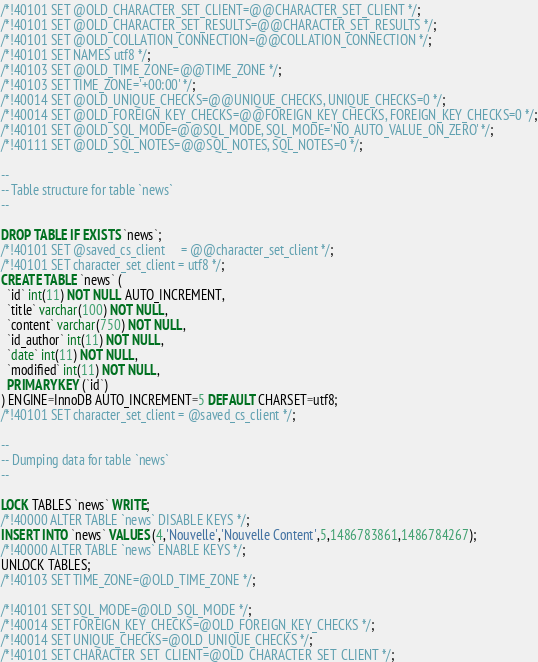<code> <loc_0><loc_0><loc_500><loc_500><_SQL_>/*!40101 SET @OLD_CHARACTER_SET_CLIENT=@@CHARACTER_SET_CLIENT */;
/*!40101 SET @OLD_CHARACTER_SET_RESULTS=@@CHARACTER_SET_RESULTS */;
/*!40101 SET @OLD_COLLATION_CONNECTION=@@COLLATION_CONNECTION */;
/*!40101 SET NAMES utf8 */;
/*!40103 SET @OLD_TIME_ZONE=@@TIME_ZONE */;
/*!40103 SET TIME_ZONE='+00:00' */;
/*!40014 SET @OLD_UNIQUE_CHECKS=@@UNIQUE_CHECKS, UNIQUE_CHECKS=0 */;
/*!40014 SET @OLD_FOREIGN_KEY_CHECKS=@@FOREIGN_KEY_CHECKS, FOREIGN_KEY_CHECKS=0 */;
/*!40101 SET @OLD_SQL_MODE=@@SQL_MODE, SQL_MODE='NO_AUTO_VALUE_ON_ZERO' */;
/*!40111 SET @OLD_SQL_NOTES=@@SQL_NOTES, SQL_NOTES=0 */;

--
-- Table structure for table `news`
--

DROP TABLE IF EXISTS `news`;
/*!40101 SET @saved_cs_client     = @@character_set_client */;
/*!40101 SET character_set_client = utf8 */;
CREATE TABLE `news` (
  `id` int(11) NOT NULL AUTO_INCREMENT,
  `title` varchar(100) NOT NULL,
  `content` varchar(750) NOT NULL,
  `id_author` int(11) NOT NULL,
  `date` int(11) NOT NULL,
  `modified` int(11) NOT NULL,
  PRIMARY KEY (`id`)
) ENGINE=InnoDB AUTO_INCREMENT=5 DEFAULT CHARSET=utf8;
/*!40101 SET character_set_client = @saved_cs_client */;

--
-- Dumping data for table `news`
--

LOCK TABLES `news` WRITE;
/*!40000 ALTER TABLE `news` DISABLE KEYS */;
INSERT INTO `news` VALUES (4,'Nouvelle','Nouvelle Content',5,1486783861,1486784267);
/*!40000 ALTER TABLE `news` ENABLE KEYS */;
UNLOCK TABLES;
/*!40103 SET TIME_ZONE=@OLD_TIME_ZONE */;

/*!40101 SET SQL_MODE=@OLD_SQL_MODE */;
/*!40014 SET FOREIGN_KEY_CHECKS=@OLD_FOREIGN_KEY_CHECKS */;
/*!40014 SET UNIQUE_CHECKS=@OLD_UNIQUE_CHECKS */;
/*!40101 SET CHARACTER_SET_CLIENT=@OLD_CHARACTER_SET_CLIENT */;</code> 